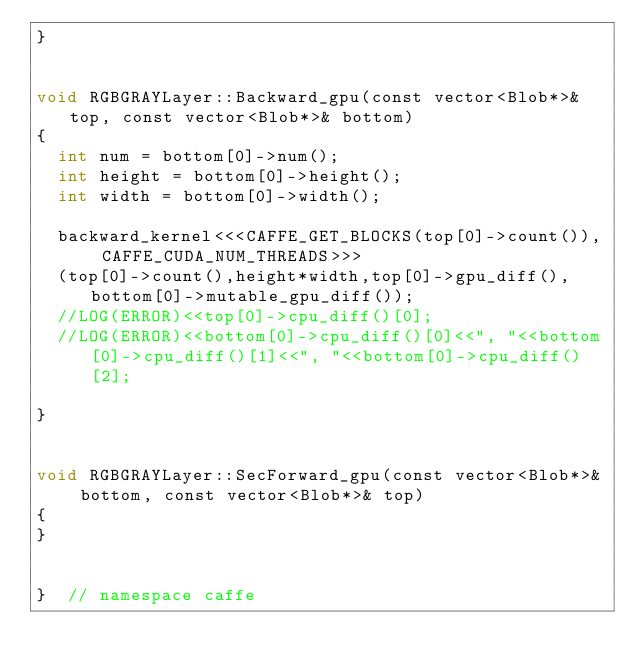<code> <loc_0><loc_0><loc_500><loc_500><_Cuda_>}


void RGBGRAYLayer::Backward_gpu(const vector<Blob*>& top, const vector<Blob*>& bottom) 
{
	int num = bottom[0]->num();
  int height = bottom[0]->height();
  int width = bottom[0]->width();
  
	backward_kernel<<<CAFFE_GET_BLOCKS(top[0]->count()), CAFFE_CUDA_NUM_THREADS>>>
	(top[0]->count(),height*width,top[0]->gpu_diff(),bottom[0]->mutable_gpu_diff());
	//LOG(ERROR)<<top[0]->cpu_diff()[0];
	//LOG(ERROR)<<bottom[0]->cpu_diff()[0]<<", "<<bottom[0]->cpu_diff()[1]<<", "<<bottom[0]->cpu_diff()[2];
	
}


void RGBGRAYLayer::SecForward_gpu(const vector<Blob*>& bottom, const vector<Blob*>& top) 
{
}


}  // namespace caffe
</code> 